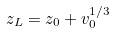<formula> <loc_0><loc_0><loc_500><loc_500>z _ { L } = z _ { 0 } + v _ { 0 } ^ { 1 / 3 }</formula> 